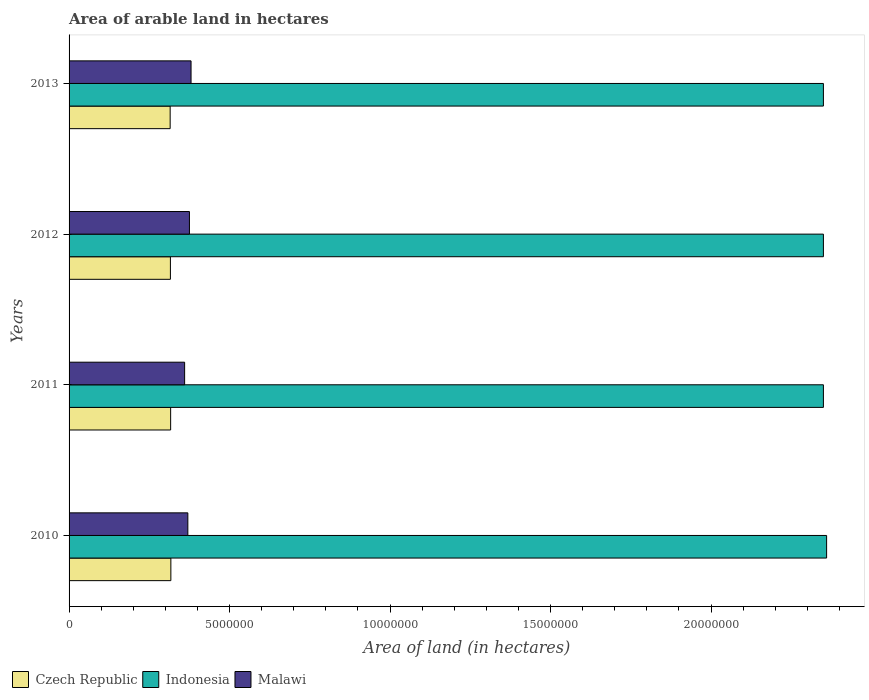How many groups of bars are there?
Provide a succinct answer. 4. Are the number of bars per tick equal to the number of legend labels?
Ensure brevity in your answer.  Yes. Are the number of bars on each tick of the Y-axis equal?
Your answer should be very brief. Yes. What is the label of the 2nd group of bars from the top?
Your response must be concise. 2012. What is the total arable land in Malawi in 2013?
Keep it short and to the point. 3.80e+06. Across all years, what is the maximum total arable land in Malawi?
Your response must be concise. 3.80e+06. Across all years, what is the minimum total arable land in Malawi?
Provide a succinct answer. 3.60e+06. In which year was the total arable land in Malawi minimum?
Your answer should be very brief. 2011. What is the total total arable land in Czech Republic in the graph?
Your answer should be very brief. 1.26e+07. What is the difference between the total arable land in Indonesia in 2012 and that in 2013?
Provide a short and direct response. 0. What is the difference between the total arable land in Indonesia in 2011 and the total arable land in Czech Republic in 2012?
Provide a short and direct response. 2.03e+07. What is the average total arable land in Indonesia per year?
Keep it short and to the point. 2.35e+07. In the year 2012, what is the difference between the total arable land in Indonesia and total arable land in Malawi?
Keep it short and to the point. 1.98e+07. What is the ratio of the total arable land in Czech Republic in 2010 to that in 2011?
Offer a very short reply. 1. Is the total arable land in Czech Republic in 2010 less than that in 2012?
Your answer should be very brief. No. Is the difference between the total arable land in Indonesia in 2010 and 2012 greater than the difference between the total arable land in Malawi in 2010 and 2012?
Give a very brief answer. Yes. What is the difference between the highest and the second highest total arable land in Czech Republic?
Give a very brief answer. 7000. What is the difference between the highest and the lowest total arable land in Indonesia?
Your answer should be very brief. 1.00e+05. What does the 1st bar from the top in 2011 represents?
Your response must be concise. Malawi. Are all the bars in the graph horizontal?
Give a very brief answer. Yes. How many years are there in the graph?
Offer a very short reply. 4. What is the difference between two consecutive major ticks on the X-axis?
Offer a very short reply. 5.00e+06. Are the values on the major ticks of X-axis written in scientific E-notation?
Your answer should be compact. No. Does the graph contain any zero values?
Offer a terse response. No. How many legend labels are there?
Your response must be concise. 3. How are the legend labels stacked?
Keep it short and to the point. Horizontal. What is the title of the graph?
Provide a succinct answer. Area of arable land in hectares. Does "Central African Republic" appear as one of the legend labels in the graph?
Make the answer very short. No. What is the label or title of the X-axis?
Offer a terse response. Area of land (in hectares). What is the label or title of the Y-axis?
Your answer should be compact. Years. What is the Area of land (in hectares) in Czech Republic in 2010?
Provide a short and direct response. 3.17e+06. What is the Area of land (in hectares) of Indonesia in 2010?
Keep it short and to the point. 2.36e+07. What is the Area of land (in hectares) in Malawi in 2010?
Your answer should be very brief. 3.70e+06. What is the Area of land (in hectares) in Czech Republic in 2011?
Give a very brief answer. 3.16e+06. What is the Area of land (in hectares) in Indonesia in 2011?
Provide a short and direct response. 2.35e+07. What is the Area of land (in hectares) of Malawi in 2011?
Your answer should be compact. 3.60e+06. What is the Area of land (in hectares) in Czech Republic in 2012?
Provide a succinct answer. 3.16e+06. What is the Area of land (in hectares) of Indonesia in 2012?
Your answer should be very brief. 2.35e+07. What is the Area of land (in hectares) of Malawi in 2012?
Offer a terse response. 3.75e+06. What is the Area of land (in hectares) of Czech Republic in 2013?
Offer a very short reply. 3.15e+06. What is the Area of land (in hectares) of Indonesia in 2013?
Ensure brevity in your answer.  2.35e+07. What is the Area of land (in hectares) of Malawi in 2013?
Make the answer very short. 3.80e+06. Across all years, what is the maximum Area of land (in hectares) in Czech Republic?
Your answer should be compact. 3.17e+06. Across all years, what is the maximum Area of land (in hectares) of Indonesia?
Keep it short and to the point. 2.36e+07. Across all years, what is the maximum Area of land (in hectares) in Malawi?
Offer a terse response. 3.80e+06. Across all years, what is the minimum Area of land (in hectares) in Czech Republic?
Give a very brief answer. 3.15e+06. Across all years, what is the minimum Area of land (in hectares) of Indonesia?
Make the answer very short. 2.35e+07. Across all years, what is the minimum Area of land (in hectares) of Malawi?
Your answer should be compact. 3.60e+06. What is the total Area of land (in hectares) of Czech Republic in the graph?
Provide a short and direct response. 1.26e+07. What is the total Area of land (in hectares) of Indonesia in the graph?
Keep it short and to the point. 9.41e+07. What is the total Area of land (in hectares) of Malawi in the graph?
Keep it short and to the point. 1.48e+07. What is the difference between the Area of land (in hectares) in Czech Republic in 2010 and that in 2011?
Keep it short and to the point. 7000. What is the difference between the Area of land (in hectares) in Indonesia in 2010 and that in 2011?
Your response must be concise. 1.00e+05. What is the difference between the Area of land (in hectares) in Malawi in 2010 and that in 2011?
Offer a terse response. 1.00e+05. What is the difference between the Area of land (in hectares) in Czech Republic in 2010 and that in 2012?
Your answer should be very brief. 1.40e+04. What is the difference between the Area of land (in hectares) in Czech Republic in 2010 and that in 2013?
Your answer should be compact. 2.20e+04. What is the difference between the Area of land (in hectares) of Malawi in 2010 and that in 2013?
Give a very brief answer. -1.00e+05. What is the difference between the Area of land (in hectares) of Czech Republic in 2011 and that in 2012?
Your answer should be very brief. 7000. What is the difference between the Area of land (in hectares) in Indonesia in 2011 and that in 2012?
Provide a succinct answer. 0. What is the difference between the Area of land (in hectares) of Czech Republic in 2011 and that in 2013?
Your answer should be compact. 1.50e+04. What is the difference between the Area of land (in hectares) in Czech Republic in 2012 and that in 2013?
Your response must be concise. 8000. What is the difference between the Area of land (in hectares) in Czech Republic in 2010 and the Area of land (in hectares) in Indonesia in 2011?
Provide a succinct answer. -2.03e+07. What is the difference between the Area of land (in hectares) of Czech Republic in 2010 and the Area of land (in hectares) of Malawi in 2011?
Provide a succinct answer. -4.29e+05. What is the difference between the Area of land (in hectares) in Czech Republic in 2010 and the Area of land (in hectares) in Indonesia in 2012?
Your response must be concise. -2.03e+07. What is the difference between the Area of land (in hectares) of Czech Republic in 2010 and the Area of land (in hectares) of Malawi in 2012?
Offer a terse response. -5.79e+05. What is the difference between the Area of land (in hectares) of Indonesia in 2010 and the Area of land (in hectares) of Malawi in 2012?
Your response must be concise. 1.98e+07. What is the difference between the Area of land (in hectares) in Czech Republic in 2010 and the Area of land (in hectares) in Indonesia in 2013?
Offer a terse response. -2.03e+07. What is the difference between the Area of land (in hectares) in Czech Republic in 2010 and the Area of land (in hectares) in Malawi in 2013?
Give a very brief answer. -6.29e+05. What is the difference between the Area of land (in hectares) of Indonesia in 2010 and the Area of land (in hectares) of Malawi in 2013?
Provide a succinct answer. 1.98e+07. What is the difference between the Area of land (in hectares) in Czech Republic in 2011 and the Area of land (in hectares) in Indonesia in 2012?
Make the answer very short. -2.03e+07. What is the difference between the Area of land (in hectares) in Czech Republic in 2011 and the Area of land (in hectares) in Malawi in 2012?
Your answer should be compact. -5.86e+05. What is the difference between the Area of land (in hectares) of Indonesia in 2011 and the Area of land (in hectares) of Malawi in 2012?
Your response must be concise. 1.98e+07. What is the difference between the Area of land (in hectares) of Czech Republic in 2011 and the Area of land (in hectares) of Indonesia in 2013?
Ensure brevity in your answer.  -2.03e+07. What is the difference between the Area of land (in hectares) in Czech Republic in 2011 and the Area of land (in hectares) in Malawi in 2013?
Give a very brief answer. -6.36e+05. What is the difference between the Area of land (in hectares) in Indonesia in 2011 and the Area of land (in hectares) in Malawi in 2013?
Make the answer very short. 1.97e+07. What is the difference between the Area of land (in hectares) of Czech Republic in 2012 and the Area of land (in hectares) of Indonesia in 2013?
Your answer should be compact. -2.03e+07. What is the difference between the Area of land (in hectares) of Czech Republic in 2012 and the Area of land (in hectares) of Malawi in 2013?
Offer a terse response. -6.43e+05. What is the difference between the Area of land (in hectares) of Indonesia in 2012 and the Area of land (in hectares) of Malawi in 2013?
Your answer should be very brief. 1.97e+07. What is the average Area of land (in hectares) of Czech Republic per year?
Ensure brevity in your answer.  3.16e+06. What is the average Area of land (in hectares) of Indonesia per year?
Offer a very short reply. 2.35e+07. What is the average Area of land (in hectares) in Malawi per year?
Your response must be concise. 3.71e+06. In the year 2010, what is the difference between the Area of land (in hectares) in Czech Republic and Area of land (in hectares) in Indonesia?
Offer a very short reply. -2.04e+07. In the year 2010, what is the difference between the Area of land (in hectares) of Czech Republic and Area of land (in hectares) of Malawi?
Provide a succinct answer. -5.29e+05. In the year 2010, what is the difference between the Area of land (in hectares) in Indonesia and Area of land (in hectares) in Malawi?
Offer a terse response. 1.99e+07. In the year 2011, what is the difference between the Area of land (in hectares) in Czech Republic and Area of land (in hectares) in Indonesia?
Your response must be concise. -2.03e+07. In the year 2011, what is the difference between the Area of land (in hectares) in Czech Republic and Area of land (in hectares) in Malawi?
Give a very brief answer. -4.36e+05. In the year 2011, what is the difference between the Area of land (in hectares) in Indonesia and Area of land (in hectares) in Malawi?
Your answer should be very brief. 1.99e+07. In the year 2012, what is the difference between the Area of land (in hectares) of Czech Republic and Area of land (in hectares) of Indonesia?
Your response must be concise. -2.03e+07. In the year 2012, what is the difference between the Area of land (in hectares) in Czech Republic and Area of land (in hectares) in Malawi?
Provide a short and direct response. -5.93e+05. In the year 2012, what is the difference between the Area of land (in hectares) in Indonesia and Area of land (in hectares) in Malawi?
Your answer should be compact. 1.98e+07. In the year 2013, what is the difference between the Area of land (in hectares) of Czech Republic and Area of land (in hectares) of Indonesia?
Your response must be concise. -2.04e+07. In the year 2013, what is the difference between the Area of land (in hectares) of Czech Republic and Area of land (in hectares) of Malawi?
Keep it short and to the point. -6.51e+05. In the year 2013, what is the difference between the Area of land (in hectares) in Indonesia and Area of land (in hectares) in Malawi?
Offer a terse response. 1.97e+07. What is the ratio of the Area of land (in hectares) of Indonesia in 2010 to that in 2011?
Your response must be concise. 1. What is the ratio of the Area of land (in hectares) of Malawi in 2010 to that in 2011?
Your answer should be compact. 1.03. What is the ratio of the Area of land (in hectares) of Czech Republic in 2010 to that in 2012?
Give a very brief answer. 1. What is the ratio of the Area of land (in hectares) of Malawi in 2010 to that in 2012?
Offer a very short reply. 0.99. What is the ratio of the Area of land (in hectares) in Indonesia in 2010 to that in 2013?
Keep it short and to the point. 1. What is the ratio of the Area of land (in hectares) of Malawi in 2010 to that in 2013?
Provide a short and direct response. 0.97. What is the ratio of the Area of land (in hectares) in Czech Republic in 2011 to that in 2012?
Provide a succinct answer. 1. What is the ratio of the Area of land (in hectares) of Indonesia in 2011 to that in 2012?
Offer a very short reply. 1. What is the ratio of the Area of land (in hectares) in Czech Republic in 2011 to that in 2013?
Offer a terse response. 1. What is the ratio of the Area of land (in hectares) in Indonesia in 2011 to that in 2013?
Your response must be concise. 1. What is the ratio of the Area of land (in hectares) in Czech Republic in 2012 to that in 2013?
Ensure brevity in your answer.  1. What is the ratio of the Area of land (in hectares) of Malawi in 2012 to that in 2013?
Make the answer very short. 0.99. What is the difference between the highest and the second highest Area of land (in hectares) of Czech Republic?
Offer a terse response. 7000. What is the difference between the highest and the second highest Area of land (in hectares) in Indonesia?
Keep it short and to the point. 1.00e+05. What is the difference between the highest and the second highest Area of land (in hectares) of Malawi?
Provide a short and direct response. 5.00e+04. What is the difference between the highest and the lowest Area of land (in hectares) in Czech Republic?
Make the answer very short. 2.20e+04. What is the difference between the highest and the lowest Area of land (in hectares) of Malawi?
Make the answer very short. 2.00e+05. 